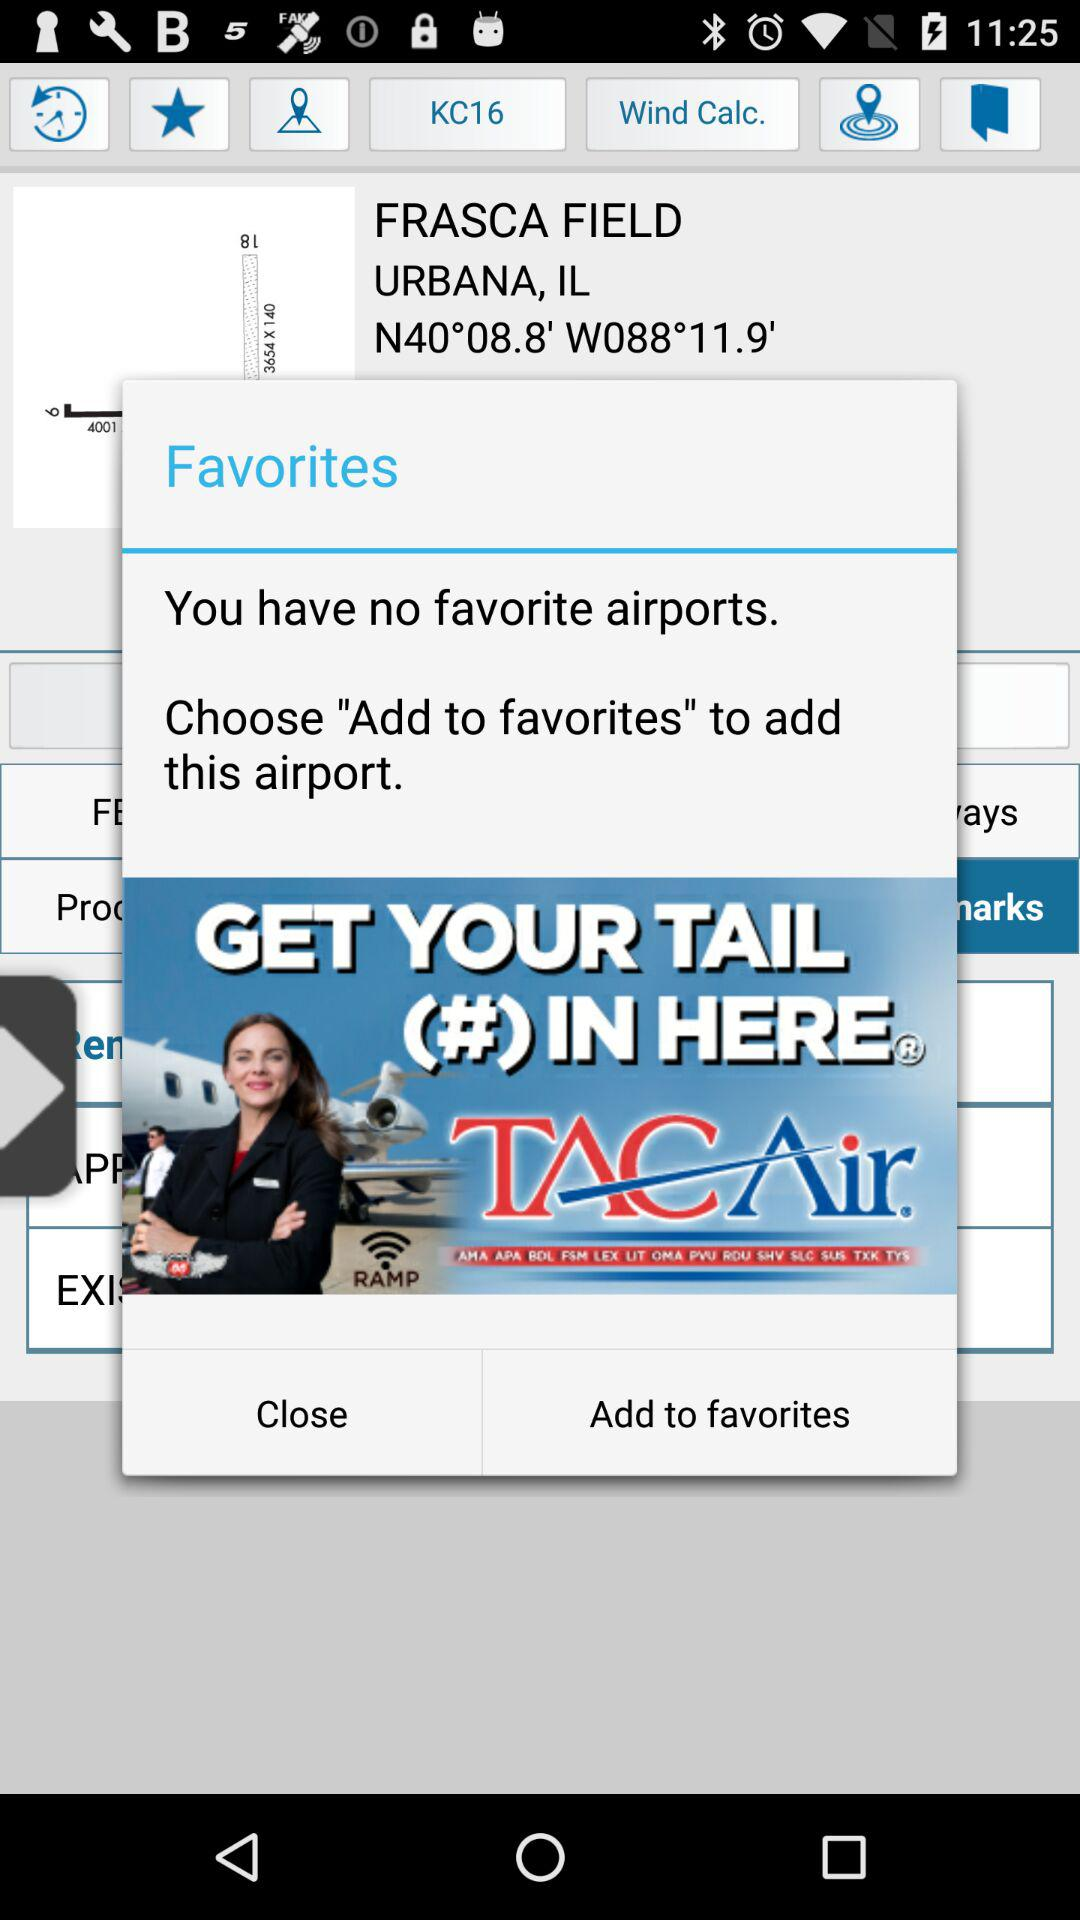How many airports have been added to favorites?
Answer the question using a single word or phrase. 0 